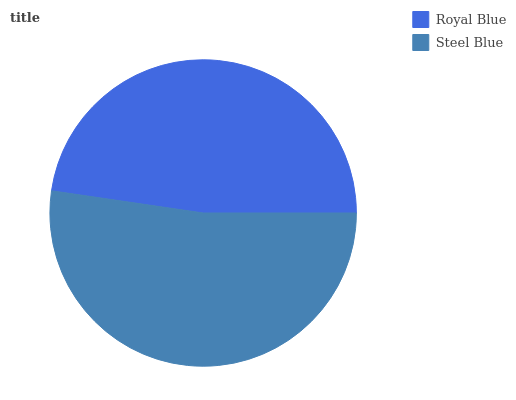Is Royal Blue the minimum?
Answer yes or no. Yes. Is Steel Blue the maximum?
Answer yes or no. Yes. Is Steel Blue the minimum?
Answer yes or no. No. Is Steel Blue greater than Royal Blue?
Answer yes or no. Yes. Is Royal Blue less than Steel Blue?
Answer yes or no. Yes. Is Royal Blue greater than Steel Blue?
Answer yes or no. No. Is Steel Blue less than Royal Blue?
Answer yes or no. No. Is Steel Blue the high median?
Answer yes or no. Yes. Is Royal Blue the low median?
Answer yes or no. Yes. Is Royal Blue the high median?
Answer yes or no. No. Is Steel Blue the low median?
Answer yes or no. No. 